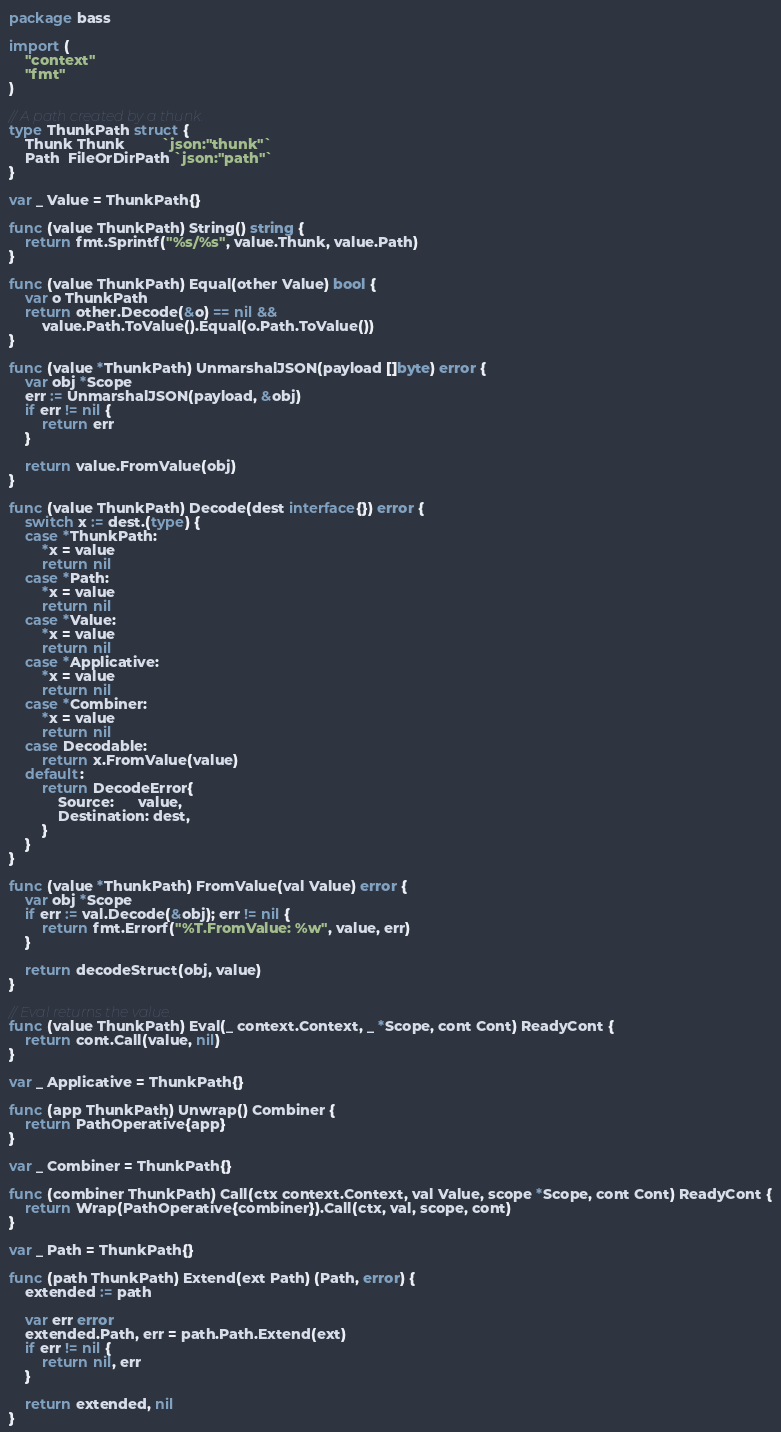<code> <loc_0><loc_0><loc_500><loc_500><_Go_>package bass

import (
	"context"
	"fmt"
)

// A path created by a thunk.
type ThunkPath struct {
	Thunk Thunk         `json:"thunk"`
	Path  FileOrDirPath `json:"path"`
}

var _ Value = ThunkPath{}

func (value ThunkPath) String() string {
	return fmt.Sprintf("%s/%s", value.Thunk, value.Path)
}

func (value ThunkPath) Equal(other Value) bool {
	var o ThunkPath
	return other.Decode(&o) == nil &&
		value.Path.ToValue().Equal(o.Path.ToValue())
}

func (value *ThunkPath) UnmarshalJSON(payload []byte) error {
	var obj *Scope
	err := UnmarshalJSON(payload, &obj)
	if err != nil {
		return err
	}

	return value.FromValue(obj)
}

func (value ThunkPath) Decode(dest interface{}) error {
	switch x := dest.(type) {
	case *ThunkPath:
		*x = value
		return nil
	case *Path:
		*x = value
		return nil
	case *Value:
		*x = value
		return nil
	case *Applicative:
		*x = value
		return nil
	case *Combiner:
		*x = value
		return nil
	case Decodable:
		return x.FromValue(value)
	default:
		return DecodeError{
			Source:      value,
			Destination: dest,
		}
	}
}

func (value *ThunkPath) FromValue(val Value) error {
	var obj *Scope
	if err := val.Decode(&obj); err != nil {
		return fmt.Errorf("%T.FromValue: %w", value, err)
	}

	return decodeStruct(obj, value)
}

// Eval returns the value.
func (value ThunkPath) Eval(_ context.Context, _ *Scope, cont Cont) ReadyCont {
	return cont.Call(value, nil)
}

var _ Applicative = ThunkPath{}

func (app ThunkPath) Unwrap() Combiner {
	return PathOperative{app}
}

var _ Combiner = ThunkPath{}

func (combiner ThunkPath) Call(ctx context.Context, val Value, scope *Scope, cont Cont) ReadyCont {
	return Wrap(PathOperative{combiner}).Call(ctx, val, scope, cont)
}

var _ Path = ThunkPath{}

func (path ThunkPath) Extend(ext Path) (Path, error) {
	extended := path

	var err error
	extended.Path, err = path.Path.Extend(ext)
	if err != nil {
		return nil, err
	}

	return extended, nil
}
</code> 